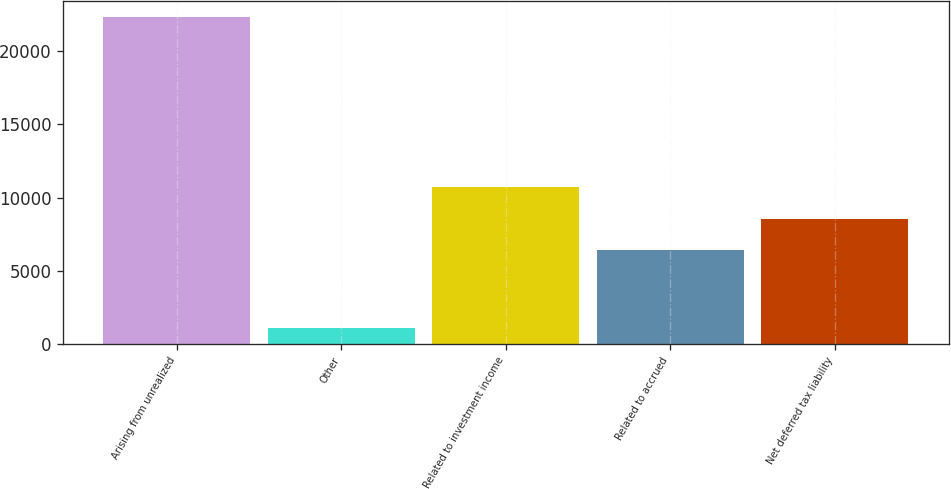Convert chart to OTSL. <chart><loc_0><loc_0><loc_500><loc_500><bar_chart><fcel>Arising from unrealized<fcel>Other<fcel>Related to investment income<fcel>Related to accrued<fcel>Net deferred tax liability<nl><fcel>22322<fcel>1069<fcel>10685.6<fcel>6435<fcel>8560.3<nl></chart> 